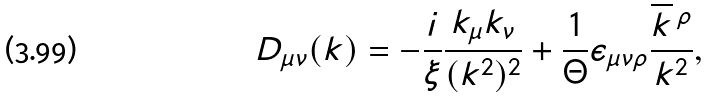<formula> <loc_0><loc_0><loc_500><loc_500>D _ { \mu \nu } ( k ) = - \frac { i } { \xi } \frac { k _ { \mu } k _ { \nu } } { ( { k } ^ { 2 } ) ^ { 2 } } + \frac { 1 } { \Theta } \epsilon _ { \mu \nu \rho } \frac { \overline { k } \, ^ { \rho } } { { k } ^ { 2 } } ,</formula> 